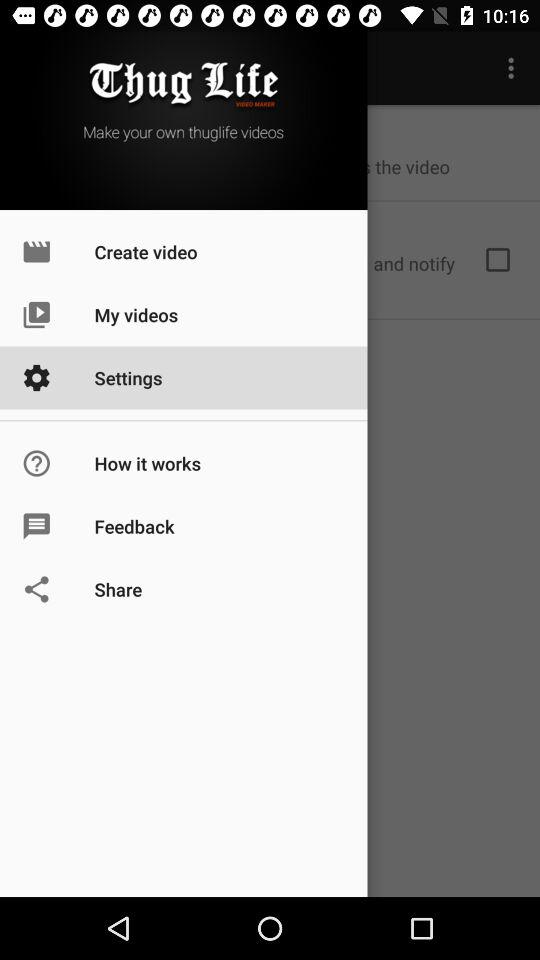What is the application name? The application name is "Thug Life VIDEO MAKER". 